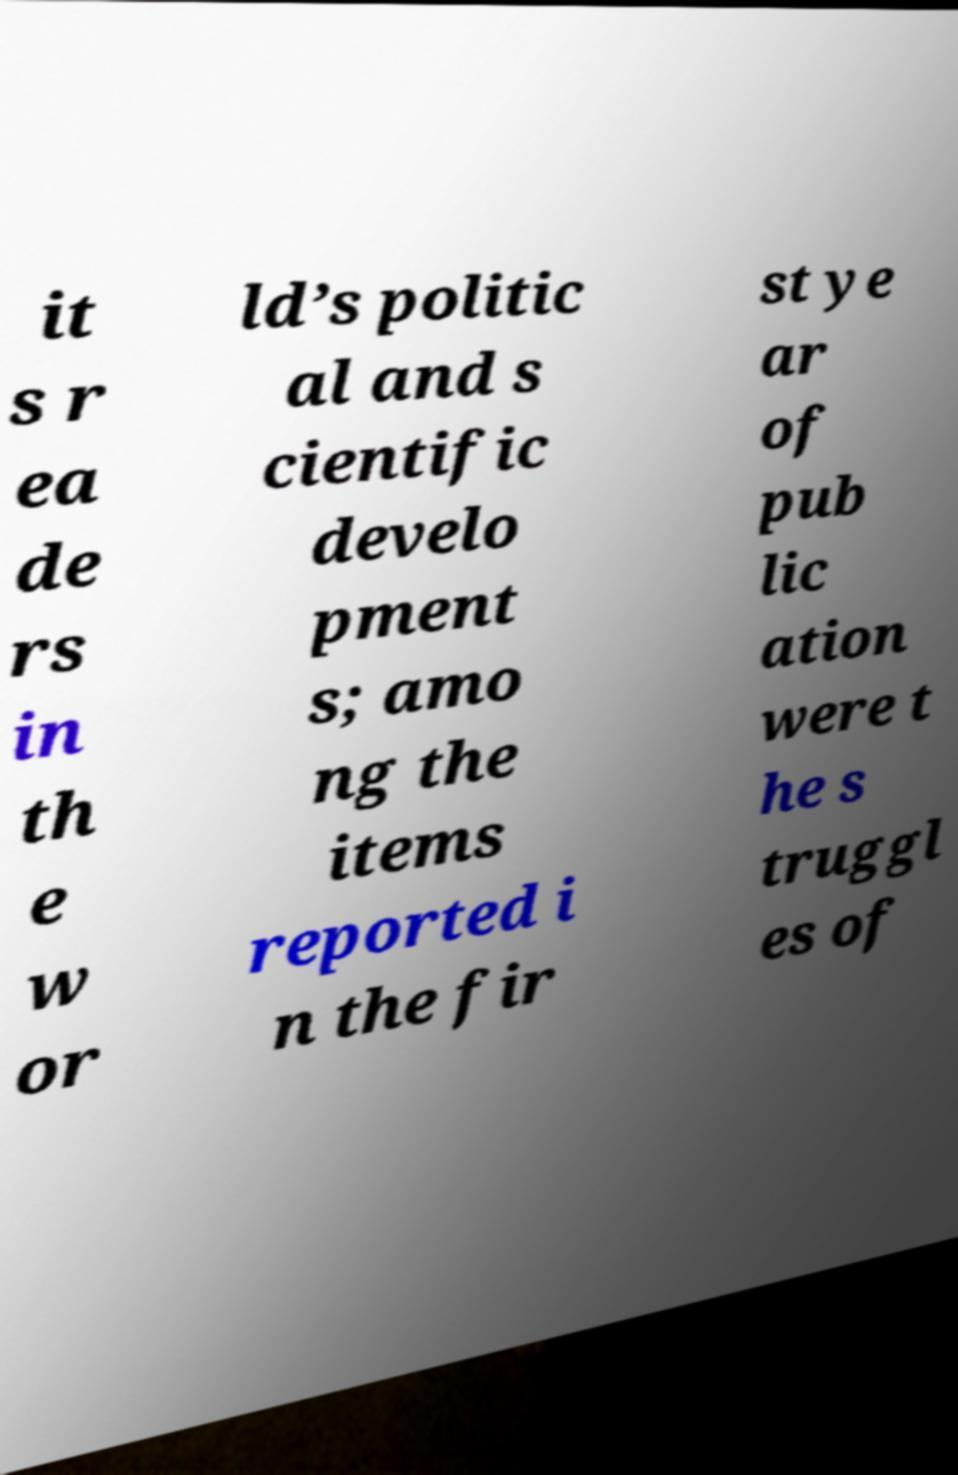Please identify and transcribe the text found in this image. it s r ea de rs in th e w or ld’s politic al and s cientific develo pment s; amo ng the items reported i n the fir st ye ar of pub lic ation were t he s truggl es of 